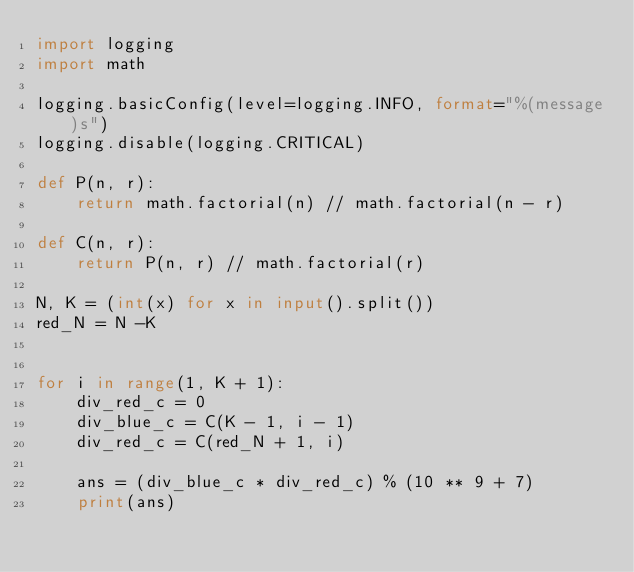<code> <loc_0><loc_0><loc_500><loc_500><_Python_>import logging
import math

logging.basicConfig(level=logging.INFO, format="%(message)s")
logging.disable(logging.CRITICAL)

def P(n, r):
    return math.factorial(n) // math.factorial(n - r)

def C(n, r):
    return P(n, r) // math.factorial(r)

N, K = (int(x) for x in input().split())
red_N = N -K


for i in range(1, K + 1):
    div_red_c = 0
    div_blue_c = C(K - 1, i - 1)
    div_red_c = C(red_N + 1, i)
    
    ans = (div_blue_c * div_red_c) % (10 ** 9 + 7)
    print(ans)</code> 